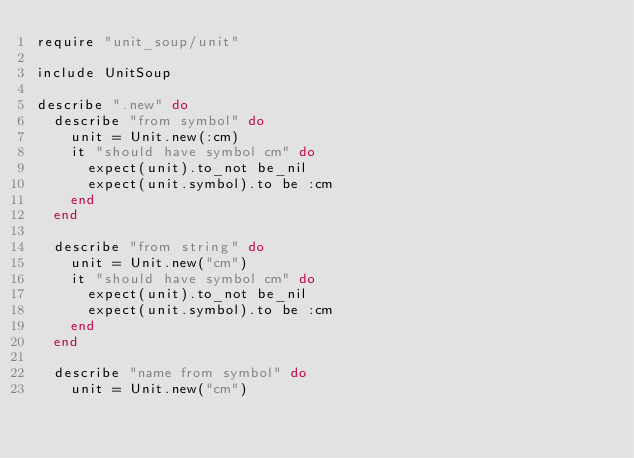Convert code to text. <code><loc_0><loc_0><loc_500><loc_500><_Ruby_>require "unit_soup/unit"

include UnitSoup

describe ".new" do
  describe "from symbol" do
    unit = Unit.new(:cm)
    it "should have symbol cm" do
      expect(unit).to_not be_nil
      expect(unit.symbol).to be :cm
    end
  end

  describe "from string" do
    unit = Unit.new("cm")
    it "should have symbol cm" do
      expect(unit).to_not be_nil
      expect(unit.symbol).to be :cm
    end
  end

  describe "name from symbol" do
    unit = Unit.new("cm")</code> 